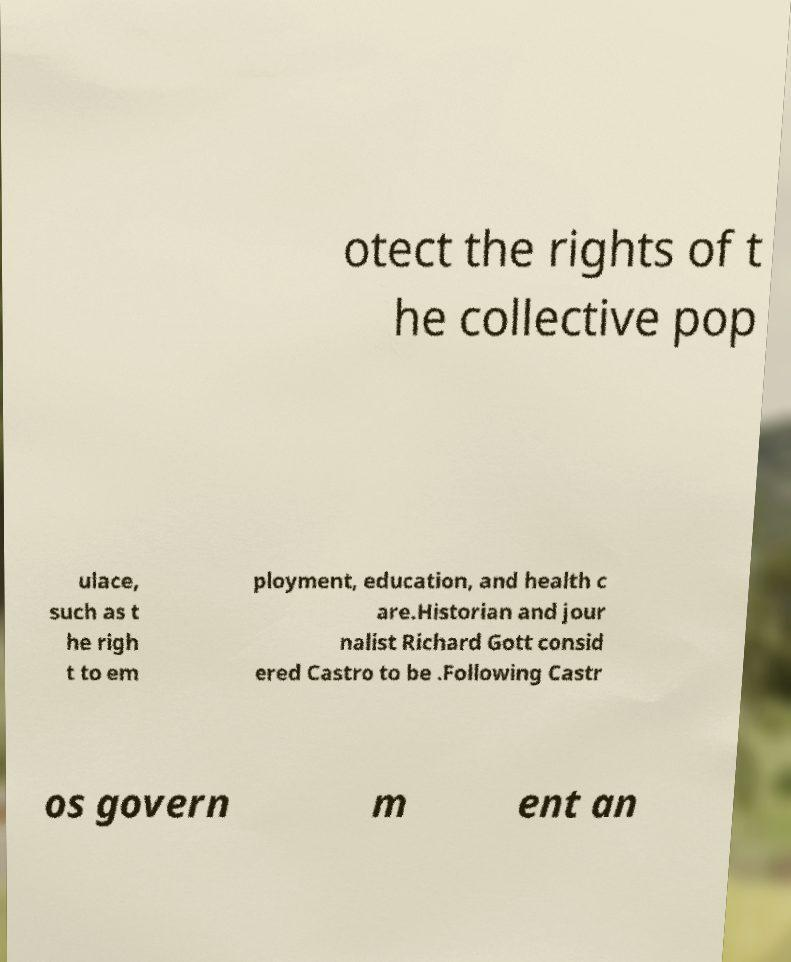Please read and relay the text visible in this image. What does it say? otect the rights of t he collective pop ulace, such as t he righ t to em ployment, education, and health c are.Historian and jour nalist Richard Gott consid ered Castro to be .Following Castr os govern m ent an 